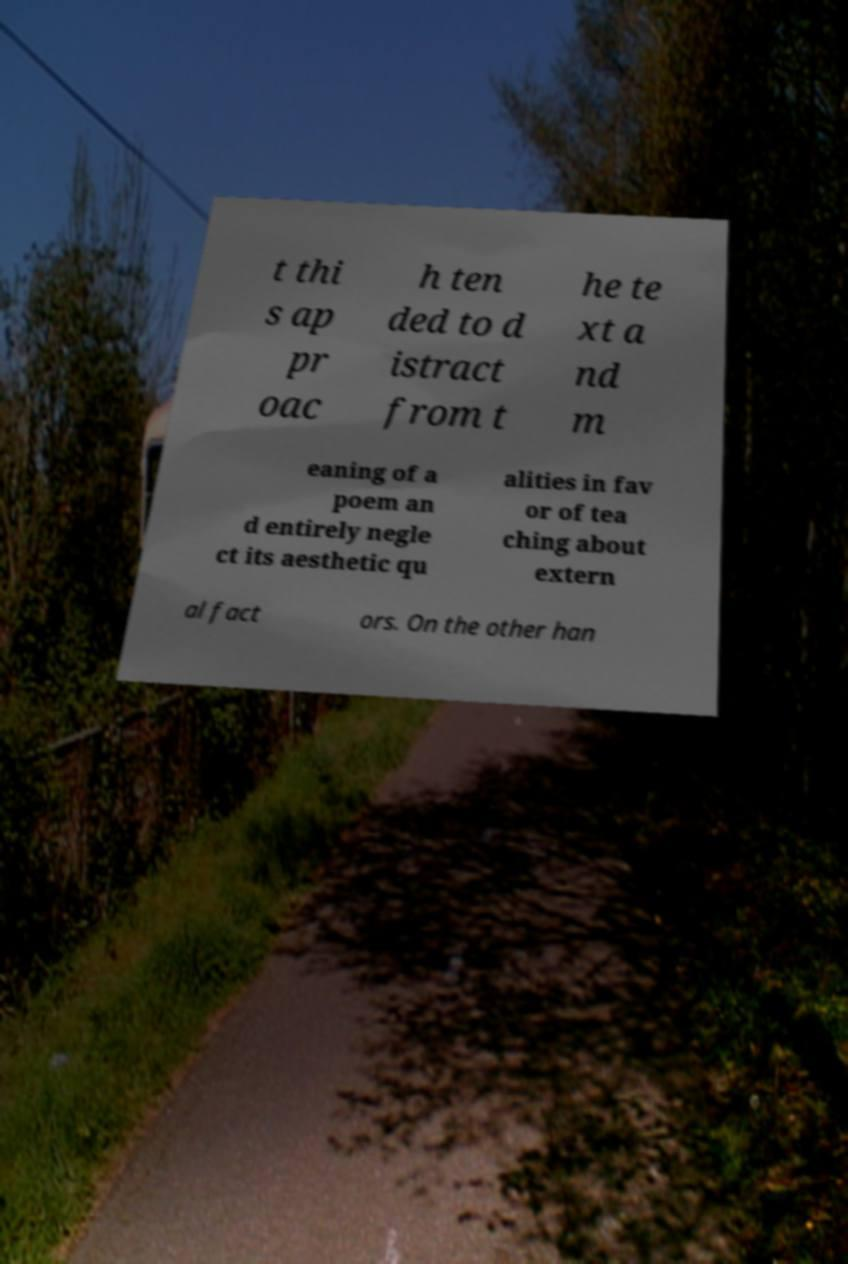Could you assist in decoding the text presented in this image and type it out clearly? t thi s ap pr oac h ten ded to d istract from t he te xt a nd m eaning of a poem an d entirely negle ct its aesthetic qu alities in fav or of tea ching about extern al fact ors. On the other han 